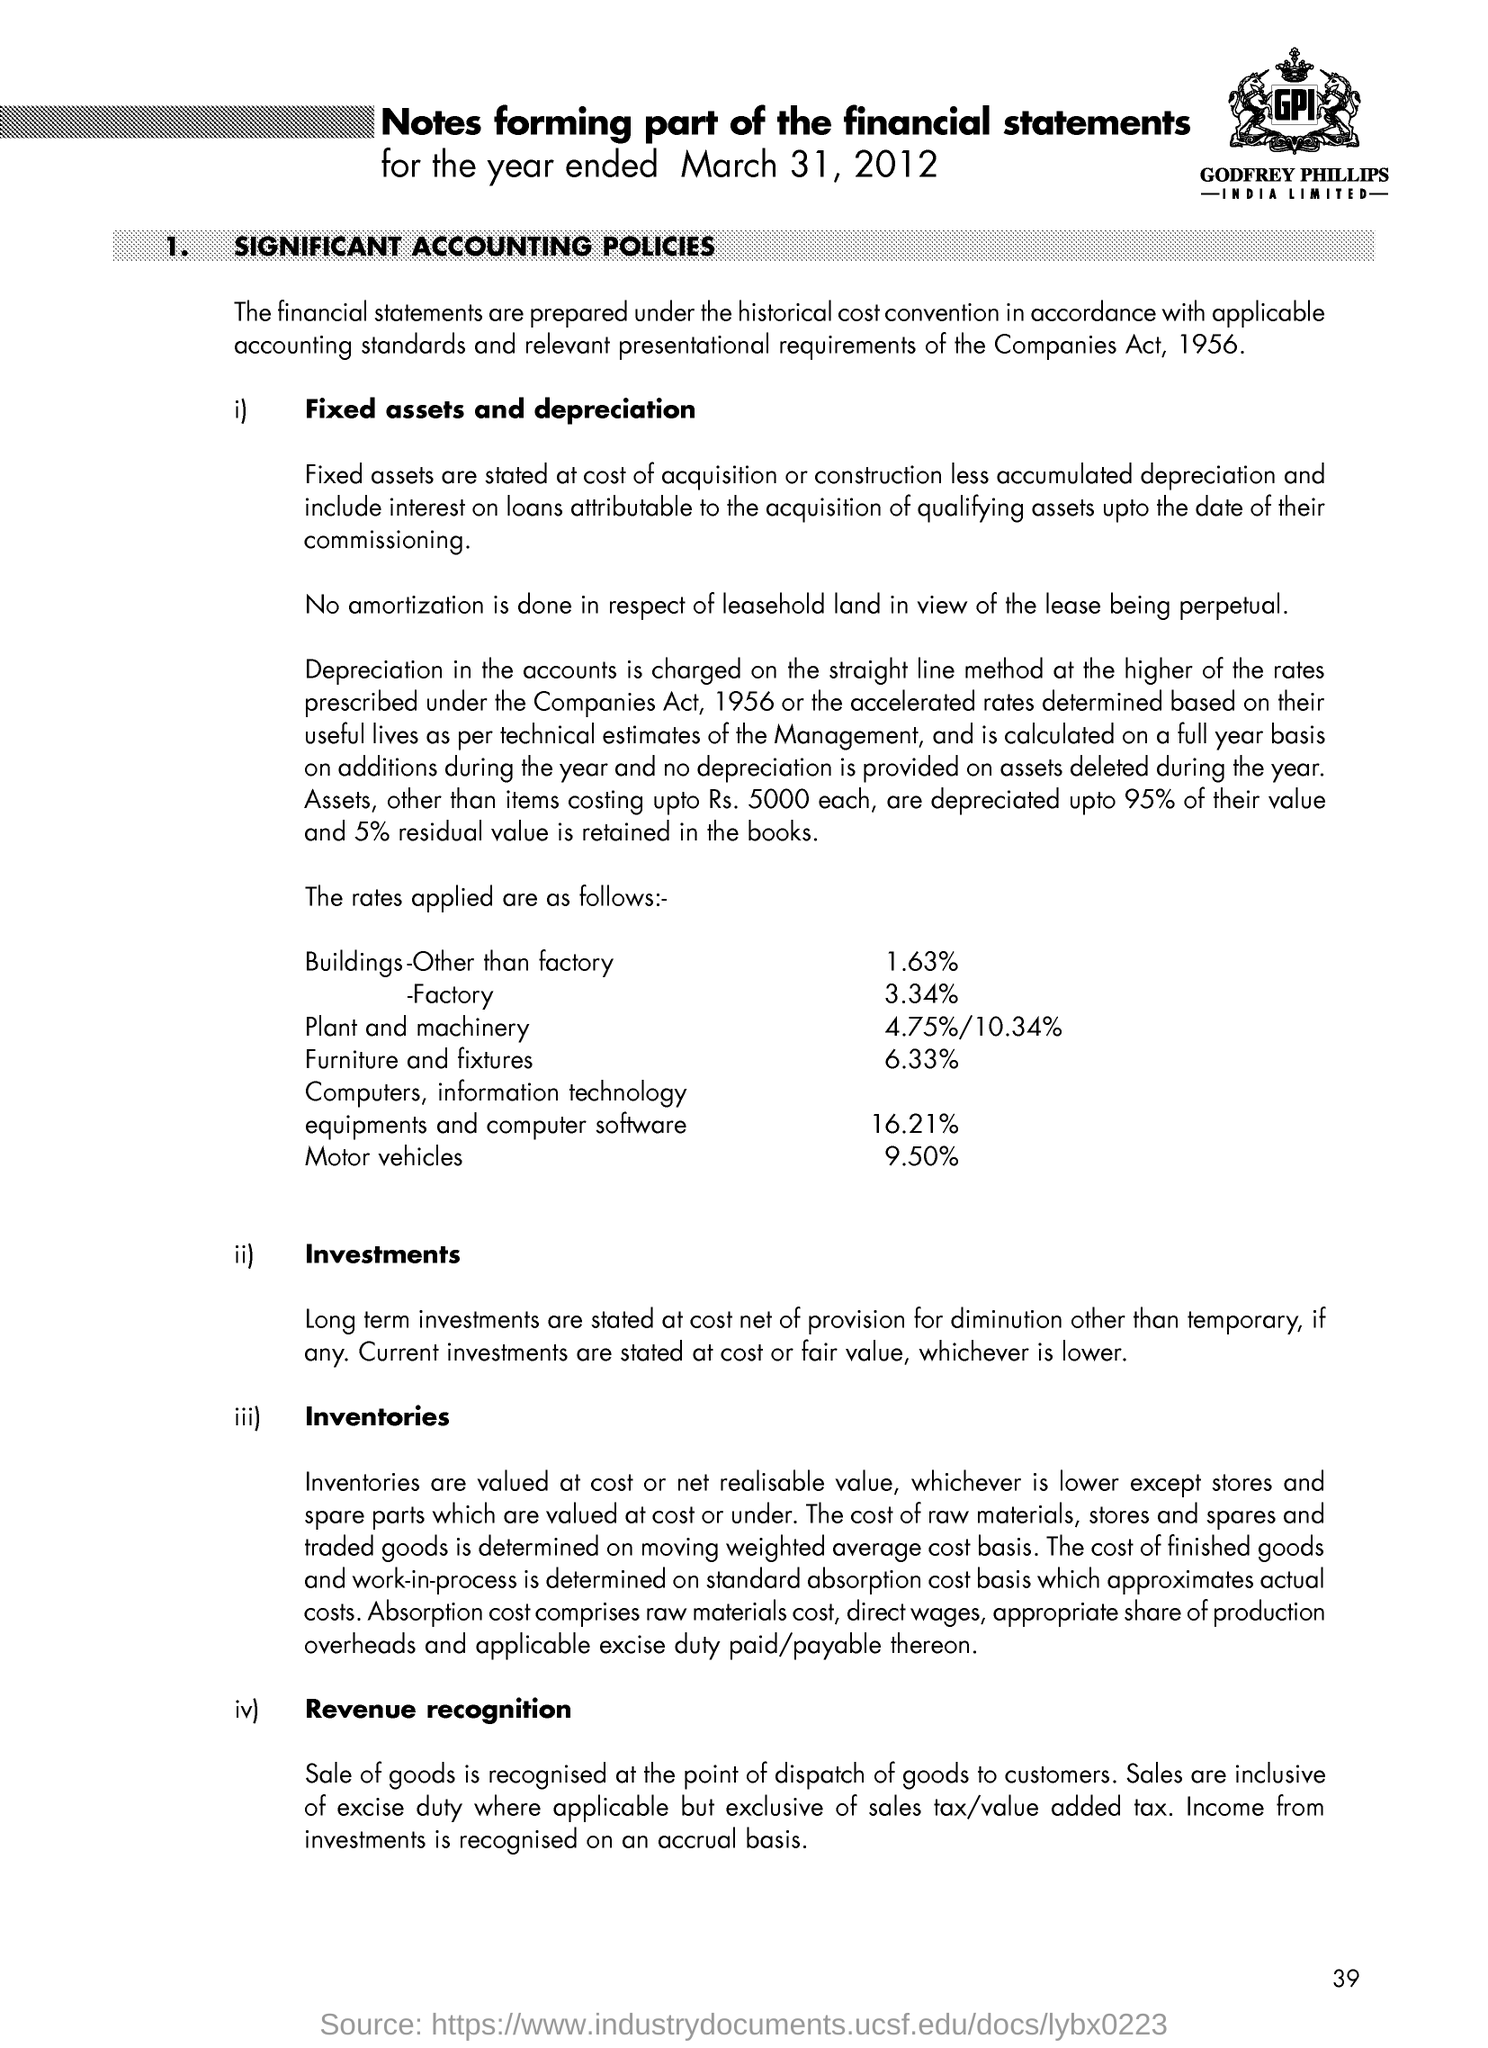Financial statements are prepared under which convention?
Provide a short and direct response. Historical cost convention. Depreciation in accounts is charged in which method?
Ensure brevity in your answer.  Straight line. 